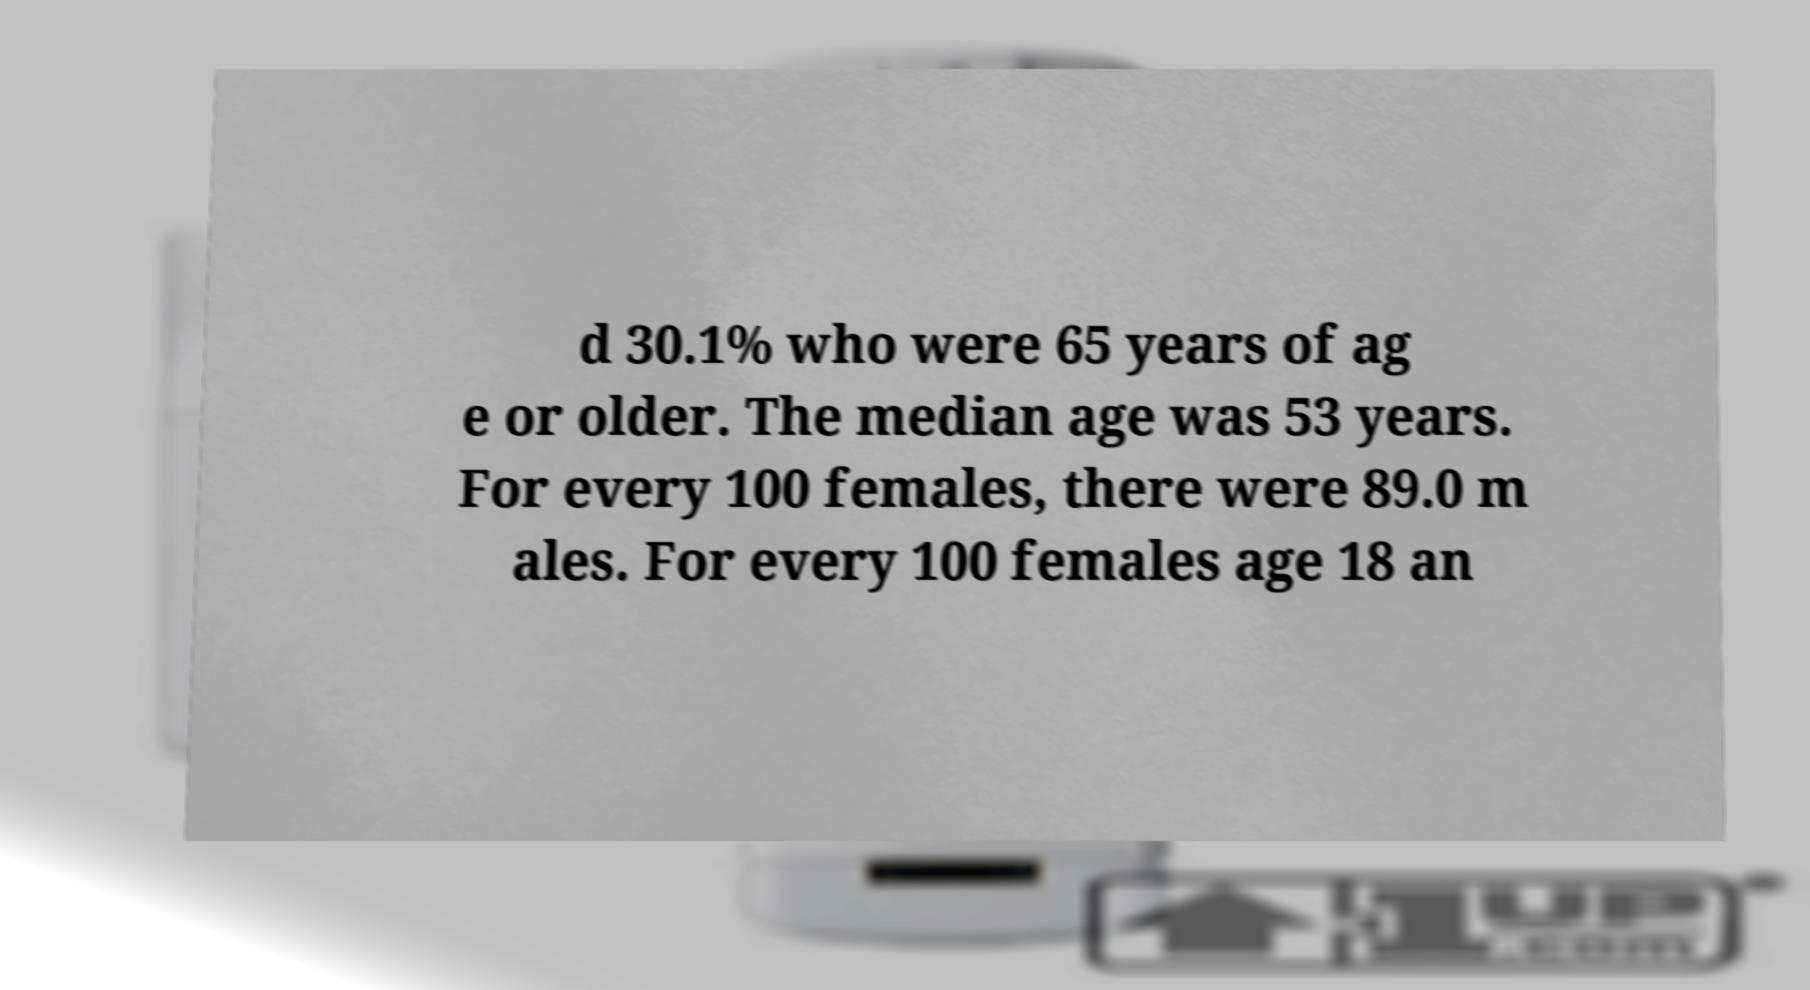Please identify and transcribe the text found in this image. d 30.1% who were 65 years of ag e or older. The median age was 53 years. For every 100 females, there were 89.0 m ales. For every 100 females age 18 an 